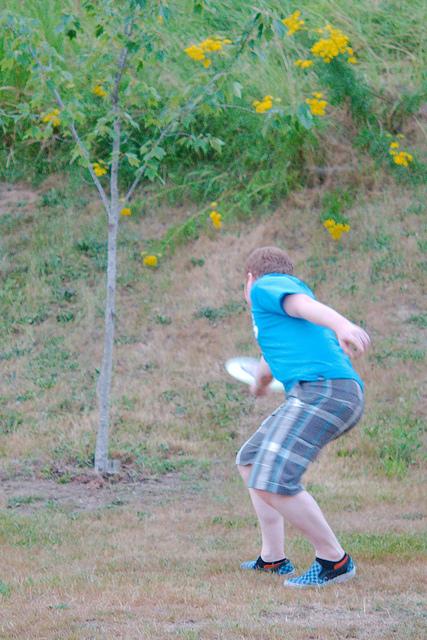What is the boy holding?
Concise answer only. Frisbee. What kind of shoes is the boy wearing?
Write a very short answer. Sneakers. How many trees are there?
Answer briefly. 1. 